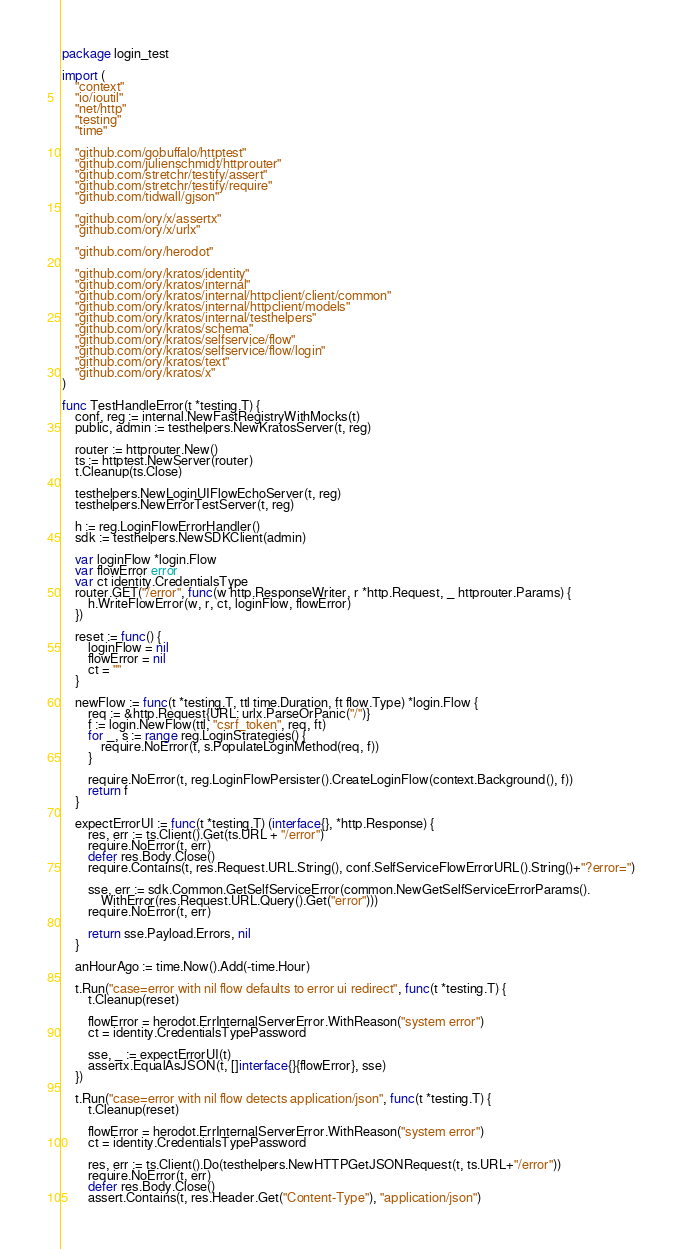<code> <loc_0><loc_0><loc_500><loc_500><_Go_>package login_test

import (
	"context"
	"io/ioutil"
	"net/http"
	"testing"
	"time"

	"github.com/gobuffalo/httptest"
	"github.com/julienschmidt/httprouter"
	"github.com/stretchr/testify/assert"
	"github.com/stretchr/testify/require"
	"github.com/tidwall/gjson"

	"github.com/ory/x/assertx"
	"github.com/ory/x/urlx"

	"github.com/ory/herodot"

	"github.com/ory/kratos/identity"
	"github.com/ory/kratos/internal"
	"github.com/ory/kratos/internal/httpclient/client/common"
	"github.com/ory/kratos/internal/httpclient/models"
	"github.com/ory/kratos/internal/testhelpers"
	"github.com/ory/kratos/schema"
	"github.com/ory/kratos/selfservice/flow"
	"github.com/ory/kratos/selfservice/flow/login"
	"github.com/ory/kratos/text"
	"github.com/ory/kratos/x"
)

func TestHandleError(t *testing.T) {
	conf, reg := internal.NewFastRegistryWithMocks(t)
	public, admin := testhelpers.NewKratosServer(t, reg)

	router := httprouter.New()
	ts := httptest.NewServer(router)
	t.Cleanup(ts.Close)

	testhelpers.NewLoginUIFlowEchoServer(t, reg)
	testhelpers.NewErrorTestServer(t, reg)

	h := reg.LoginFlowErrorHandler()
	sdk := testhelpers.NewSDKClient(admin)

	var loginFlow *login.Flow
	var flowError error
	var ct identity.CredentialsType
	router.GET("/error", func(w http.ResponseWriter, r *http.Request, _ httprouter.Params) {
		h.WriteFlowError(w, r, ct, loginFlow, flowError)
	})

	reset := func() {
		loginFlow = nil
		flowError = nil
		ct = ""
	}

	newFlow := func(t *testing.T, ttl time.Duration, ft flow.Type) *login.Flow {
		req := &http.Request{URL: urlx.ParseOrPanic("/")}
		f := login.NewFlow(ttl, "csrf_token", req, ft)
		for _, s := range reg.LoginStrategies() {
			require.NoError(t, s.PopulateLoginMethod(req, f))
		}

		require.NoError(t, reg.LoginFlowPersister().CreateLoginFlow(context.Background(), f))
		return f
	}

	expectErrorUI := func(t *testing.T) (interface{}, *http.Response) {
		res, err := ts.Client().Get(ts.URL + "/error")
		require.NoError(t, err)
		defer res.Body.Close()
		require.Contains(t, res.Request.URL.String(), conf.SelfServiceFlowErrorURL().String()+"?error=")

		sse, err := sdk.Common.GetSelfServiceError(common.NewGetSelfServiceErrorParams().
			WithError(res.Request.URL.Query().Get("error")))
		require.NoError(t, err)

		return sse.Payload.Errors, nil
	}

	anHourAgo := time.Now().Add(-time.Hour)

	t.Run("case=error with nil flow defaults to error ui redirect", func(t *testing.T) {
		t.Cleanup(reset)

		flowError = herodot.ErrInternalServerError.WithReason("system error")
		ct = identity.CredentialsTypePassword

		sse, _ := expectErrorUI(t)
		assertx.EqualAsJSON(t, []interface{}{flowError}, sse)
	})

	t.Run("case=error with nil flow detects application/json", func(t *testing.T) {
		t.Cleanup(reset)

		flowError = herodot.ErrInternalServerError.WithReason("system error")
		ct = identity.CredentialsTypePassword

		res, err := ts.Client().Do(testhelpers.NewHTTPGetJSONRequest(t, ts.URL+"/error"))
		require.NoError(t, err)
		defer res.Body.Close()
		assert.Contains(t, res.Header.Get("Content-Type"), "application/json")</code> 